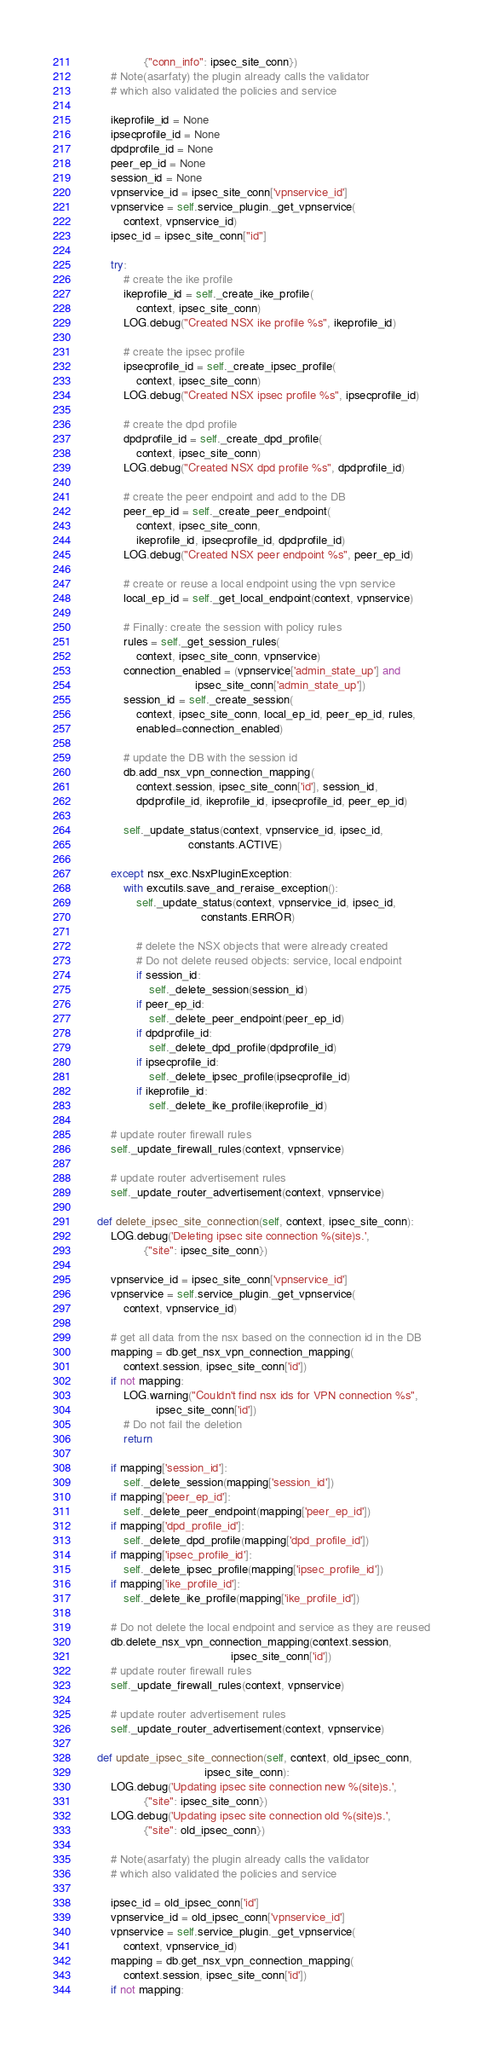<code> <loc_0><loc_0><loc_500><loc_500><_Python_>                  {"conn_info": ipsec_site_conn})
        # Note(asarfaty) the plugin already calls the validator
        # which also validated the policies and service

        ikeprofile_id = None
        ipsecprofile_id = None
        dpdprofile_id = None
        peer_ep_id = None
        session_id = None
        vpnservice_id = ipsec_site_conn['vpnservice_id']
        vpnservice = self.service_plugin._get_vpnservice(
            context, vpnservice_id)
        ipsec_id = ipsec_site_conn["id"]

        try:
            # create the ike profile
            ikeprofile_id = self._create_ike_profile(
                context, ipsec_site_conn)
            LOG.debug("Created NSX ike profile %s", ikeprofile_id)

            # create the ipsec profile
            ipsecprofile_id = self._create_ipsec_profile(
                context, ipsec_site_conn)
            LOG.debug("Created NSX ipsec profile %s", ipsecprofile_id)

            # create the dpd profile
            dpdprofile_id = self._create_dpd_profile(
                context, ipsec_site_conn)
            LOG.debug("Created NSX dpd profile %s", dpdprofile_id)

            # create the peer endpoint and add to the DB
            peer_ep_id = self._create_peer_endpoint(
                context, ipsec_site_conn,
                ikeprofile_id, ipsecprofile_id, dpdprofile_id)
            LOG.debug("Created NSX peer endpoint %s", peer_ep_id)

            # create or reuse a local endpoint using the vpn service
            local_ep_id = self._get_local_endpoint(context, vpnservice)

            # Finally: create the session with policy rules
            rules = self._get_session_rules(
                context, ipsec_site_conn, vpnservice)
            connection_enabled = (vpnservice['admin_state_up'] and
                                  ipsec_site_conn['admin_state_up'])
            session_id = self._create_session(
                context, ipsec_site_conn, local_ep_id, peer_ep_id, rules,
                enabled=connection_enabled)

            # update the DB with the session id
            db.add_nsx_vpn_connection_mapping(
                context.session, ipsec_site_conn['id'], session_id,
                dpdprofile_id, ikeprofile_id, ipsecprofile_id, peer_ep_id)

            self._update_status(context, vpnservice_id, ipsec_id,
                                constants.ACTIVE)

        except nsx_exc.NsxPluginException:
            with excutils.save_and_reraise_exception():
                self._update_status(context, vpnservice_id, ipsec_id,
                                    constants.ERROR)

                # delete the NSX objects that were already created
                # Do not delete reused objects: service, local endpoint
                if session_id:
                    self._delete_session(session_id)
                if peer_ep_id:
                    self._delete_peer_endpoint(peer_ep_id)
                if dpdprofile_id:
                    self._delete_dpd_profile(dpdprofile_id)
                if ipsecprofile_id:
                    self._delete_ipsec_profile(ipsecprofile_id)
                if ikeprofile_id:
                    self._delete_ike_profile(ikeprofile_id)

        # update router firewall rules
        self._update_firewall_rules(context, vpnservice)

        # update router advertisement rules
        self._update_router_advertisement(context, vpnservice)

    def delete_ipsec_site_connection(self, context, ipsec_site_conn):
        LOG.debug('Deleting ipsec site connection %(site)s.',
                  {"site": ipsec_site_conn})

        vpnservice_id = ipsec_site_conn['vpnservice_id']
        vpnservice = self.service_plugin._get_vpnservice(
            context, vpnservice_id)

        # get all data from the nsx based on the connection id in the DB
        mapping = db.get_nsx_vpn_connection_mapping(
            context.session, ipsec_site_conn['id'])
        if not mapping:
            LOG.warning("Couldn't find nsx ids for VPN connection %s",
                      ipsec_site_conn['id'])
            # Do not fail the deletion
            return

        if mapping['session_id']:
            self._delete_session(mapping['session_id'])
        if mapping['peer_ep_id']:
            self._delete_peer_endpoint(mapping['peer_ep_id'])
        if mapping['dpd_profile_id']:
            self._delete_dpd_profile(mapping['dpd_profile_id'])
        if mapping['ipsec_profile_id']:
            self._delete_ipsec_profile(mapping['ipsec_profile_id'])
        if mapping['ike_profile_id']:
            self._delete_ike_profile(mapping['ike_profile_id'])

        # Do not delete the local endpoint and service as they are reused
        db.delete_nsx_vpn_connection_mapping(context.session,
                                             ipsec_site_conn['id'])
        # update router firewall rules
        self._update_firewall_rules(context, vpnservice)

        # update router advertisement rules
        self._update_router_advertisement(context, vpnservice)

    def update_ipsec_site_connection(self, context, old_ipsec_conn,
                                     ipsec_site_conn):
        LOG.debug('Updating ipsec site connection new %(site)s.',
                  {"site": ipsec_site_conn})
        LOG.debug('Updating ipsec site connection old %(site)s.',
                  {"site": old_ipsec_conn})

        # Note(asarfaty) the plugin already calls the validator
        # which also validated the policies and service

        ipsec_id = old_ipsec_conn['id']
        vpnservice_id = old_ipsec_conn['vpnservice_id']
        vpnservice = self.service_plugin._get_vpnservice(
            context, vpnservice_id)
        mapping = db.get_nsx_vpn_connection_mapping(
            context.session, ipsec_site_conn['id'])
        if not mapping:</code> 